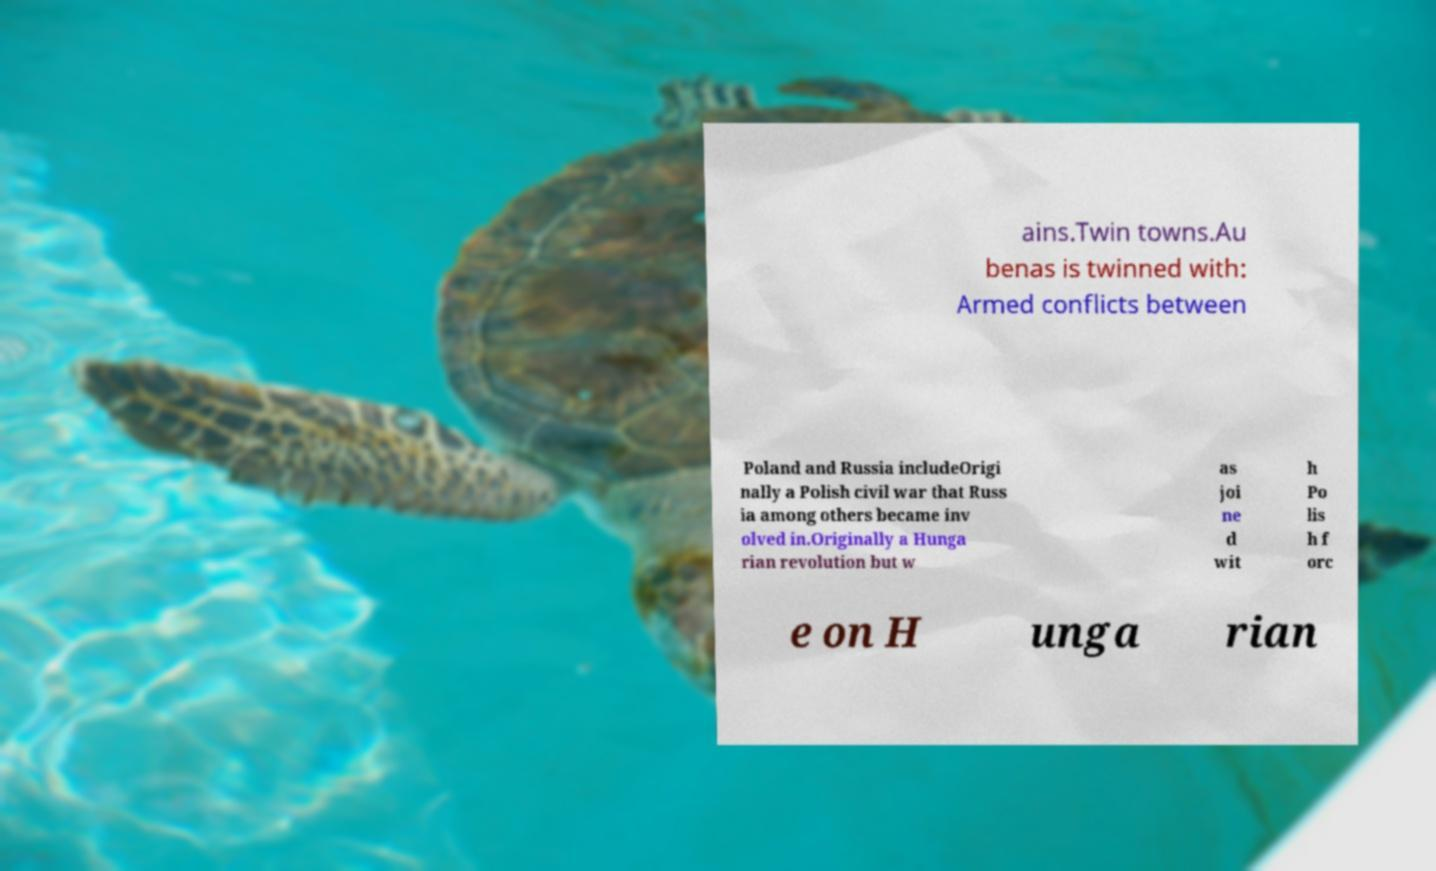Please read and relay the text visible in this image. What does it say? ains.Twin towns.Au benas is twinned with: Armed conflicts between Poland and Russia includeOrigi nally a Polish civil war that Russ ia among others became inv olved in.Originally a Hunga rian revolution but w as joi ne d wit h Po lis h f orc e on H unga rian 